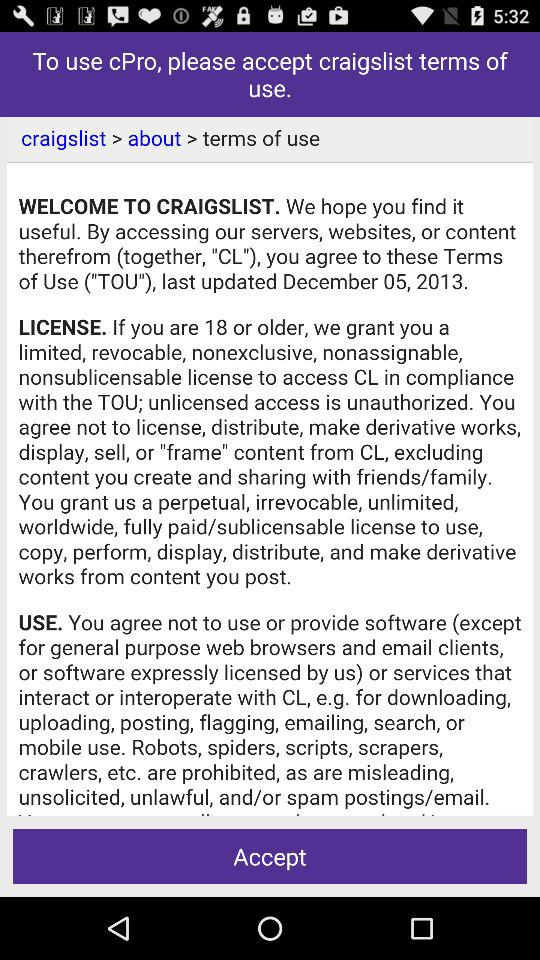When were the "Terms of Use" for "craigslist" last updated? The "Terms of Use" were last updated on December 5, 2013. 